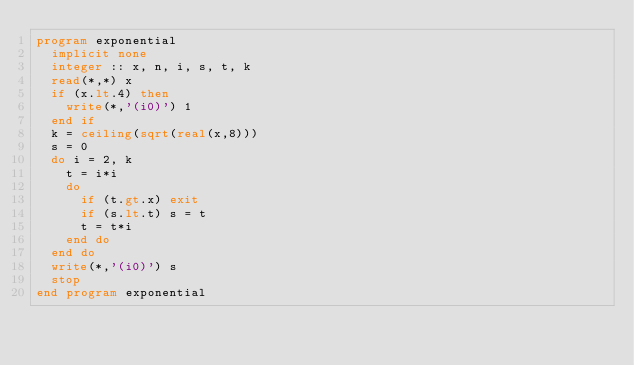Convert code to text. <code><loc_0><loc_0><loc_500><loc_500><_FORTRAN_>program exponential
  implicit none
  integer :: x, n, i, s, t, k
  read(*,*) x
  if (x.lt.4) then
    write(*,'(i0)') 1
  end if
  k = ceiling(sqrt(real(x,8)))
  s = 0
  do i = 2, k
    t = i*i
    do
      if (t.gt.x) exit
      if (s.lt.t) s = t
      t = t*i
    end do
  end do
  write(*,'(i0)') s
  stop
end program exponential</code> 